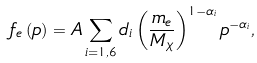<formula> <loc_0><loc_0><loc_500><loc_500>f _ { e } \left ( p \right ) = A \sum _ { i = 1 , 6 } d _ { i } \left ( \frac { m _ { e } } { M _ { \chi } } \right ) ^ { 1 - \alpha _ { i } } p ^ { - \alpha _ { i } } ,</formula> 